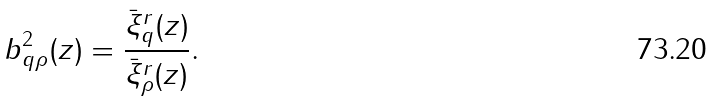<formula> <loc_0><loc_0><loc_500><loc_500>b ^ { 2 } _ { q \rho } ( z ) = \frac { \bar { \xi } ^ { r } _ { q } ( z ) } { \bar { \xi } ^ { r } _ { \rho } ( z ) } .</formula> 